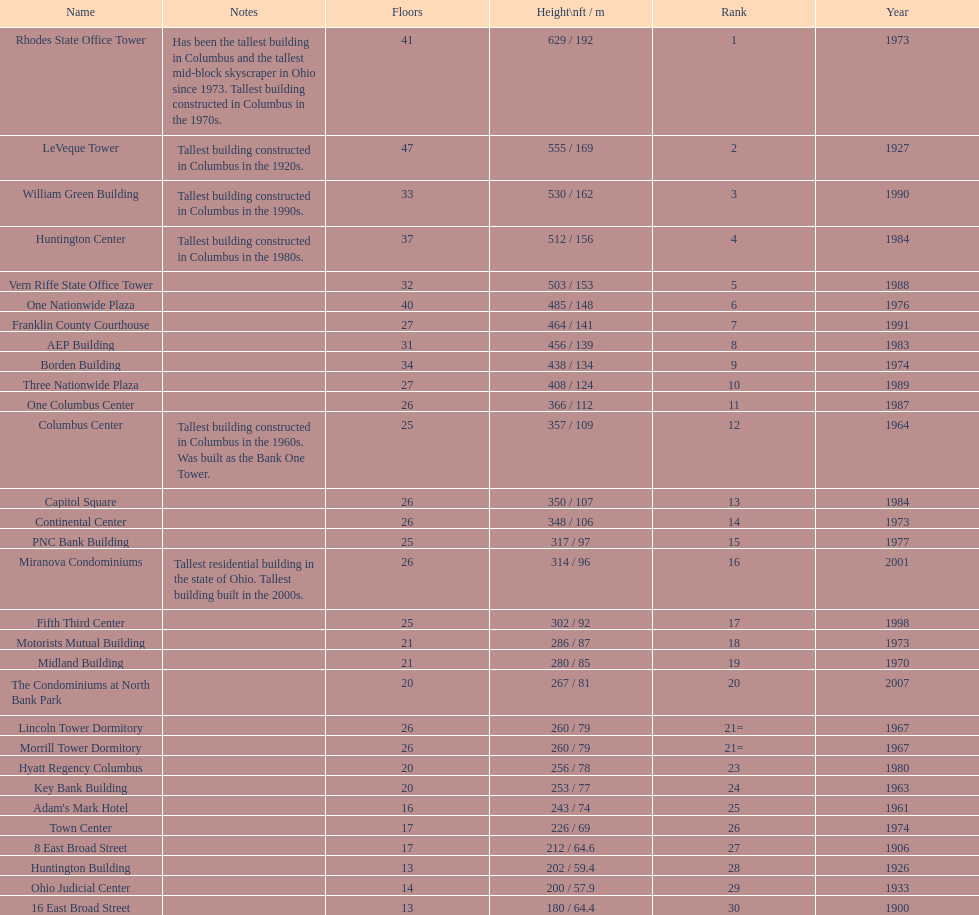What is the tallest building in columbus? Rhodes State Office Tower. 